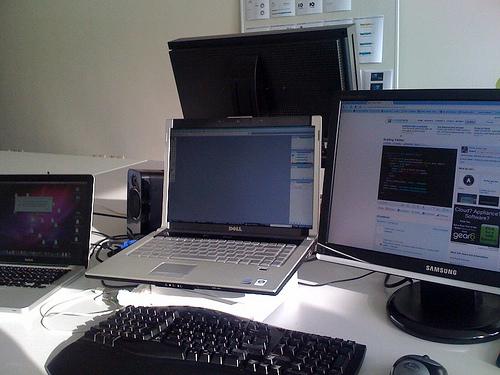What brand is the monitor to the right?
Quick response, please. Samsung. What kind of electronics are these?
Short answer required. Computers. Are there too many computers right near each other?
Write a very short answer. Yes. 